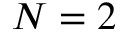<formula> <loc_0><loc_0><loc_500><loc_500>N = 2</formula> 